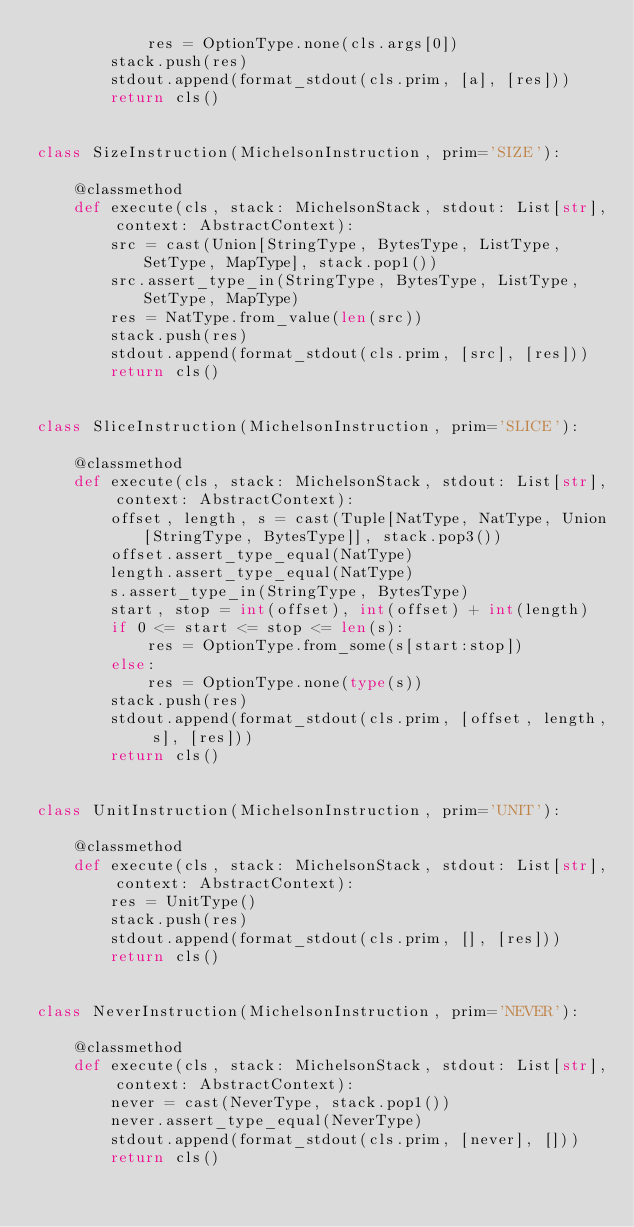<code> <loc_0><loc_0><loc_500><loc_500><_Python_>            res = OptionType.none(cls.args[0])
        stack.push(res)
        stdout.append(format_stdout(cls.prim, [a], [res]))
        return cls()


class SizeInstruction(MichelsonInstruction, prim='SIZE'):

    @classmethod
    def execute(cls, stack: MichelsonStack, stdout: List[str], context: AbstractContext):
        src = cast(Union[StringType, BytesType, ListType, SetType, MapType], stack.pop1())
        src.assert_type_in(StringType, BytesType, ListType, SetType, MapType)
        res = NatType.from_value(len(src))
        stack.push(res)
        stdout.append(format_stdout(cls.prim, [src], [res]))
        return cls()


class SliceInstruction(MichelsonInstruction, prim='SLICE'):

    @classmethod
    def execute(cls, stack: MichelsonStack, stdout: List[str], context: AbstractContext):
        offset, length, s = cast(Tuple[NatType, NatType, Union[StringType, BytesType]], stack.pop3())
        offset.assert_type_equal(NatType)
        length.assert_type_equal(NatType)
        s.assert_type_in(StringType, BytesType)
        start, stop = int(offset), int(offset) + int(length)
        if 0 <= start <= stop <= len(s):
            res = OptionType.from_some(s[start:stop])
        else:
            res = OptionType.none(type(s))
        stack.push(res)
        stdout.append(format_stdout(cls.prim, [offset, length, s], [res]))
        return cls()


class UnitInstruction(MichelsonInstruction, prim='UNIT'):

    @classmethod
    def execute(cls, stack: MichelsonStack, stdout: List[str], context: AbstractContext):
        res = UnitType()
        stack.push(res)
        stdout.append(format_stdout(cls.prim, [], [res]))
        return cls()


class NeverInstruction(MichelsonInstruction, prim='NEVER'):

    @classmethod
    def execute(cls, stack: MichelsonStack, stdout: List[str], context: AbstractContext):
        never = cast(NeverType, stack.pop1())
        never.assert_type_equal(NeverType)
        stdout.append(format_stdout(cls.prim, [never], []))
        return cls()
</code> 